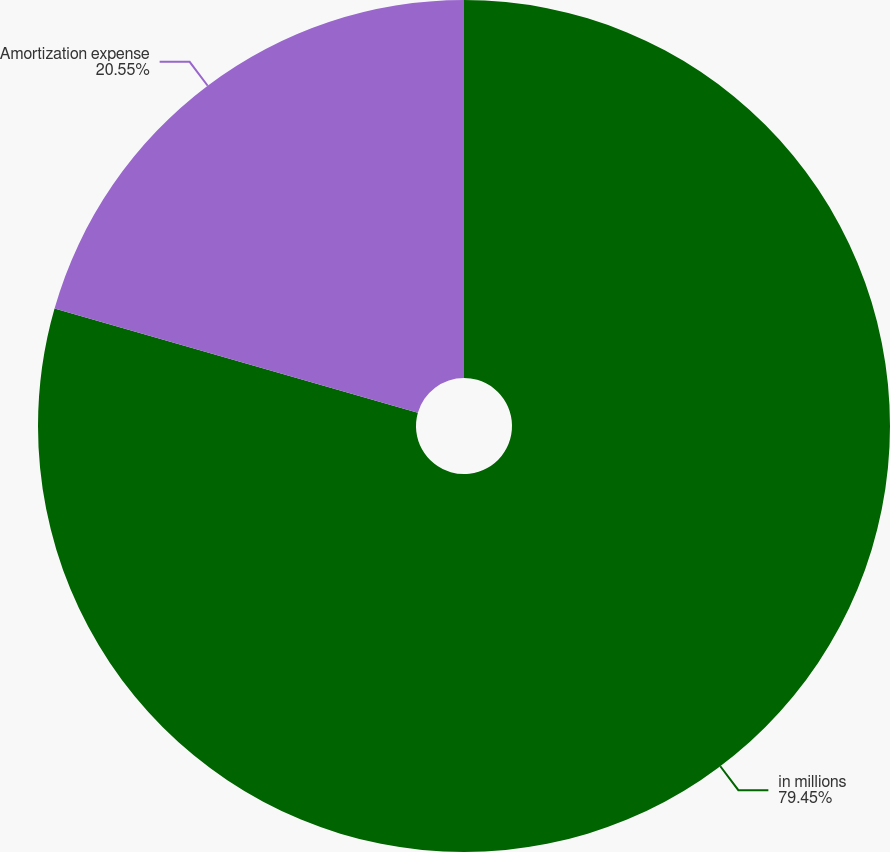<chart> <loc_0><loc_0><loc_500><loc_500><pie_chart><fcel>in millions<fcel>Amortization expense<nl><fcel>79.45%<fcel>20.55%<nl></chart> 